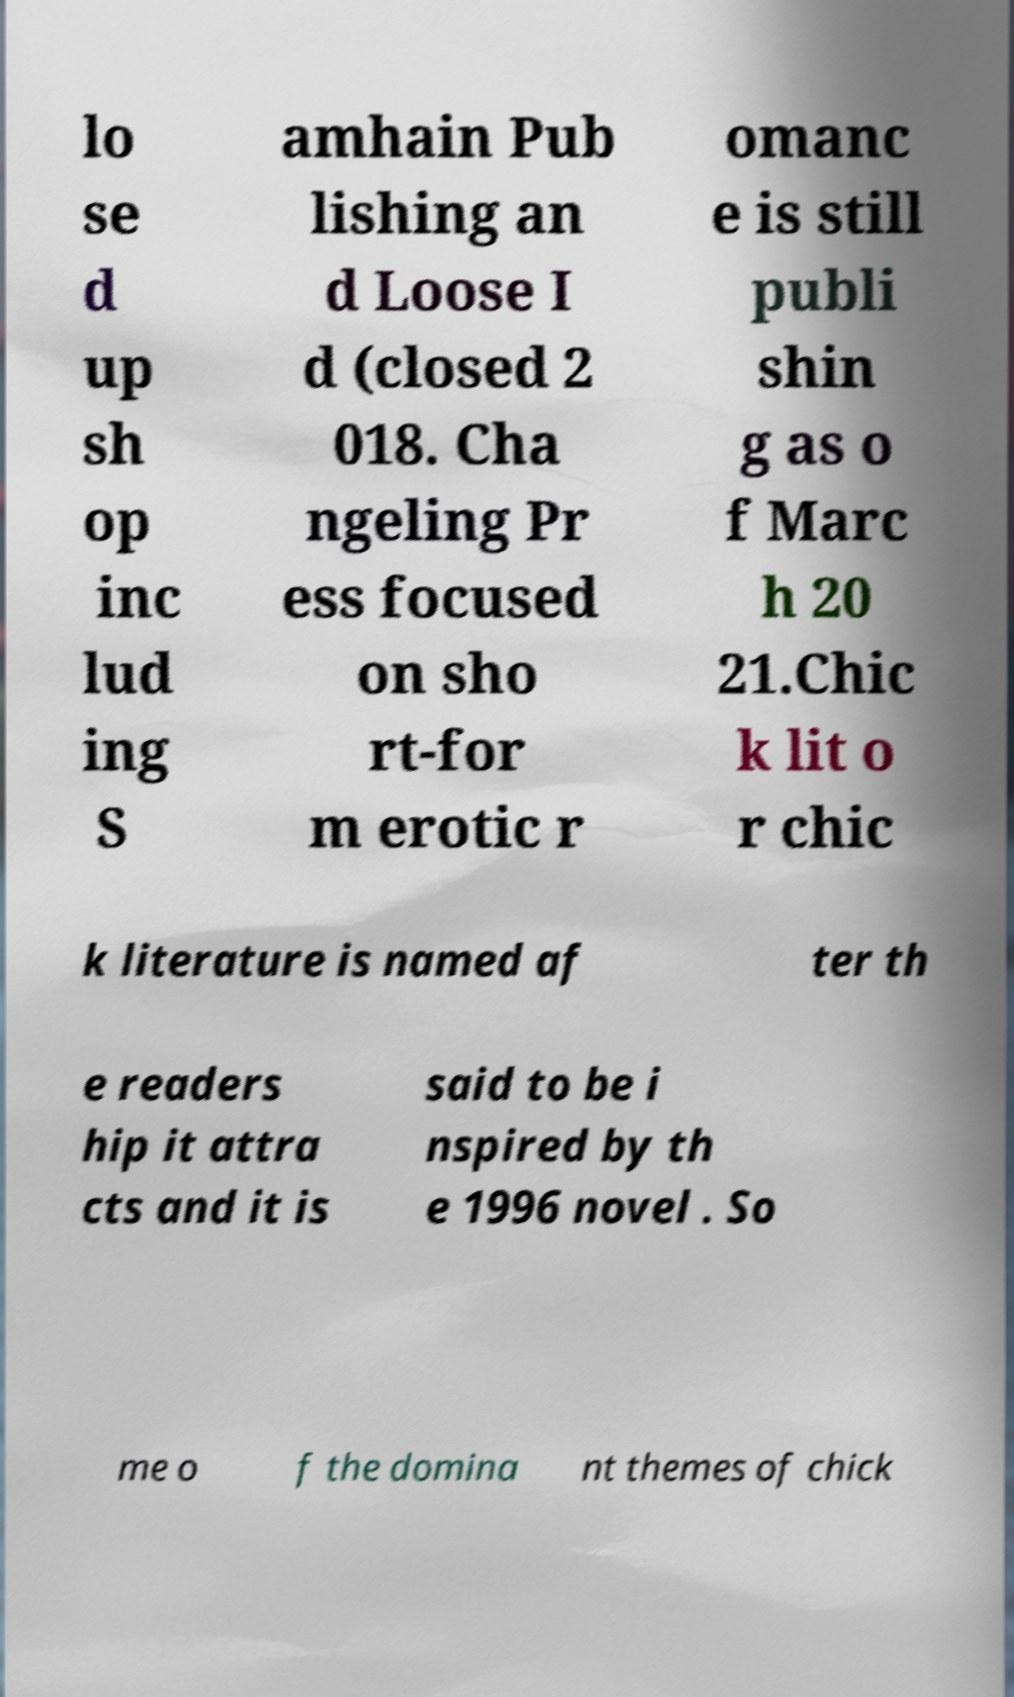For documentation purposes, I need the text within this image transcribed. Could you provide that? lo se d up sh op inc lud ing S amhain Pub lishing an d Loose I d (closed 2 018. Cha ngeling Pr ess focused on sho rt-for m erotic r omanc e is still publi shin g as o f Marc h 20 21.Chic k lit o r chic k literature is named af ter th e readers hip it attra cts and it is said to be i nspired by th e 1996 novel . So me o f the domina nt themes of chick 